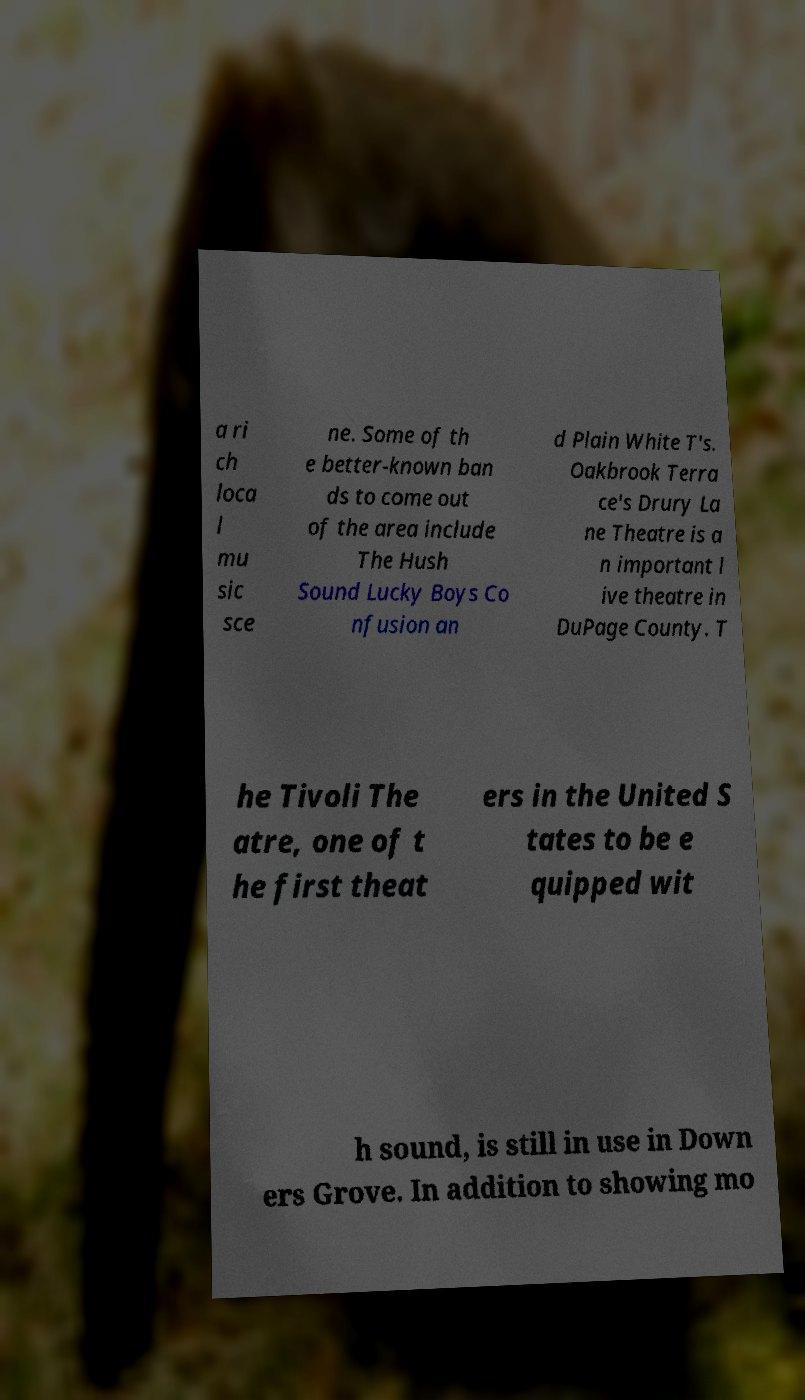Please identify and transcribe the text found in this image. a ri ch loca l mu sic sce ne. Some of th e better-known ban ds to come out of the area include The Hush Sound Lucky Boys Co nfusion an d Plain White T's. Oakbrook Terra ce's Drury La ne Theatre is a n important l ive theatre in DuPage County. T he Tivoli The atre, one of t he first theat ers in the United S tates to be e quipped wit h sound, is still in use in Down ers Grove. In addition to showing mo 